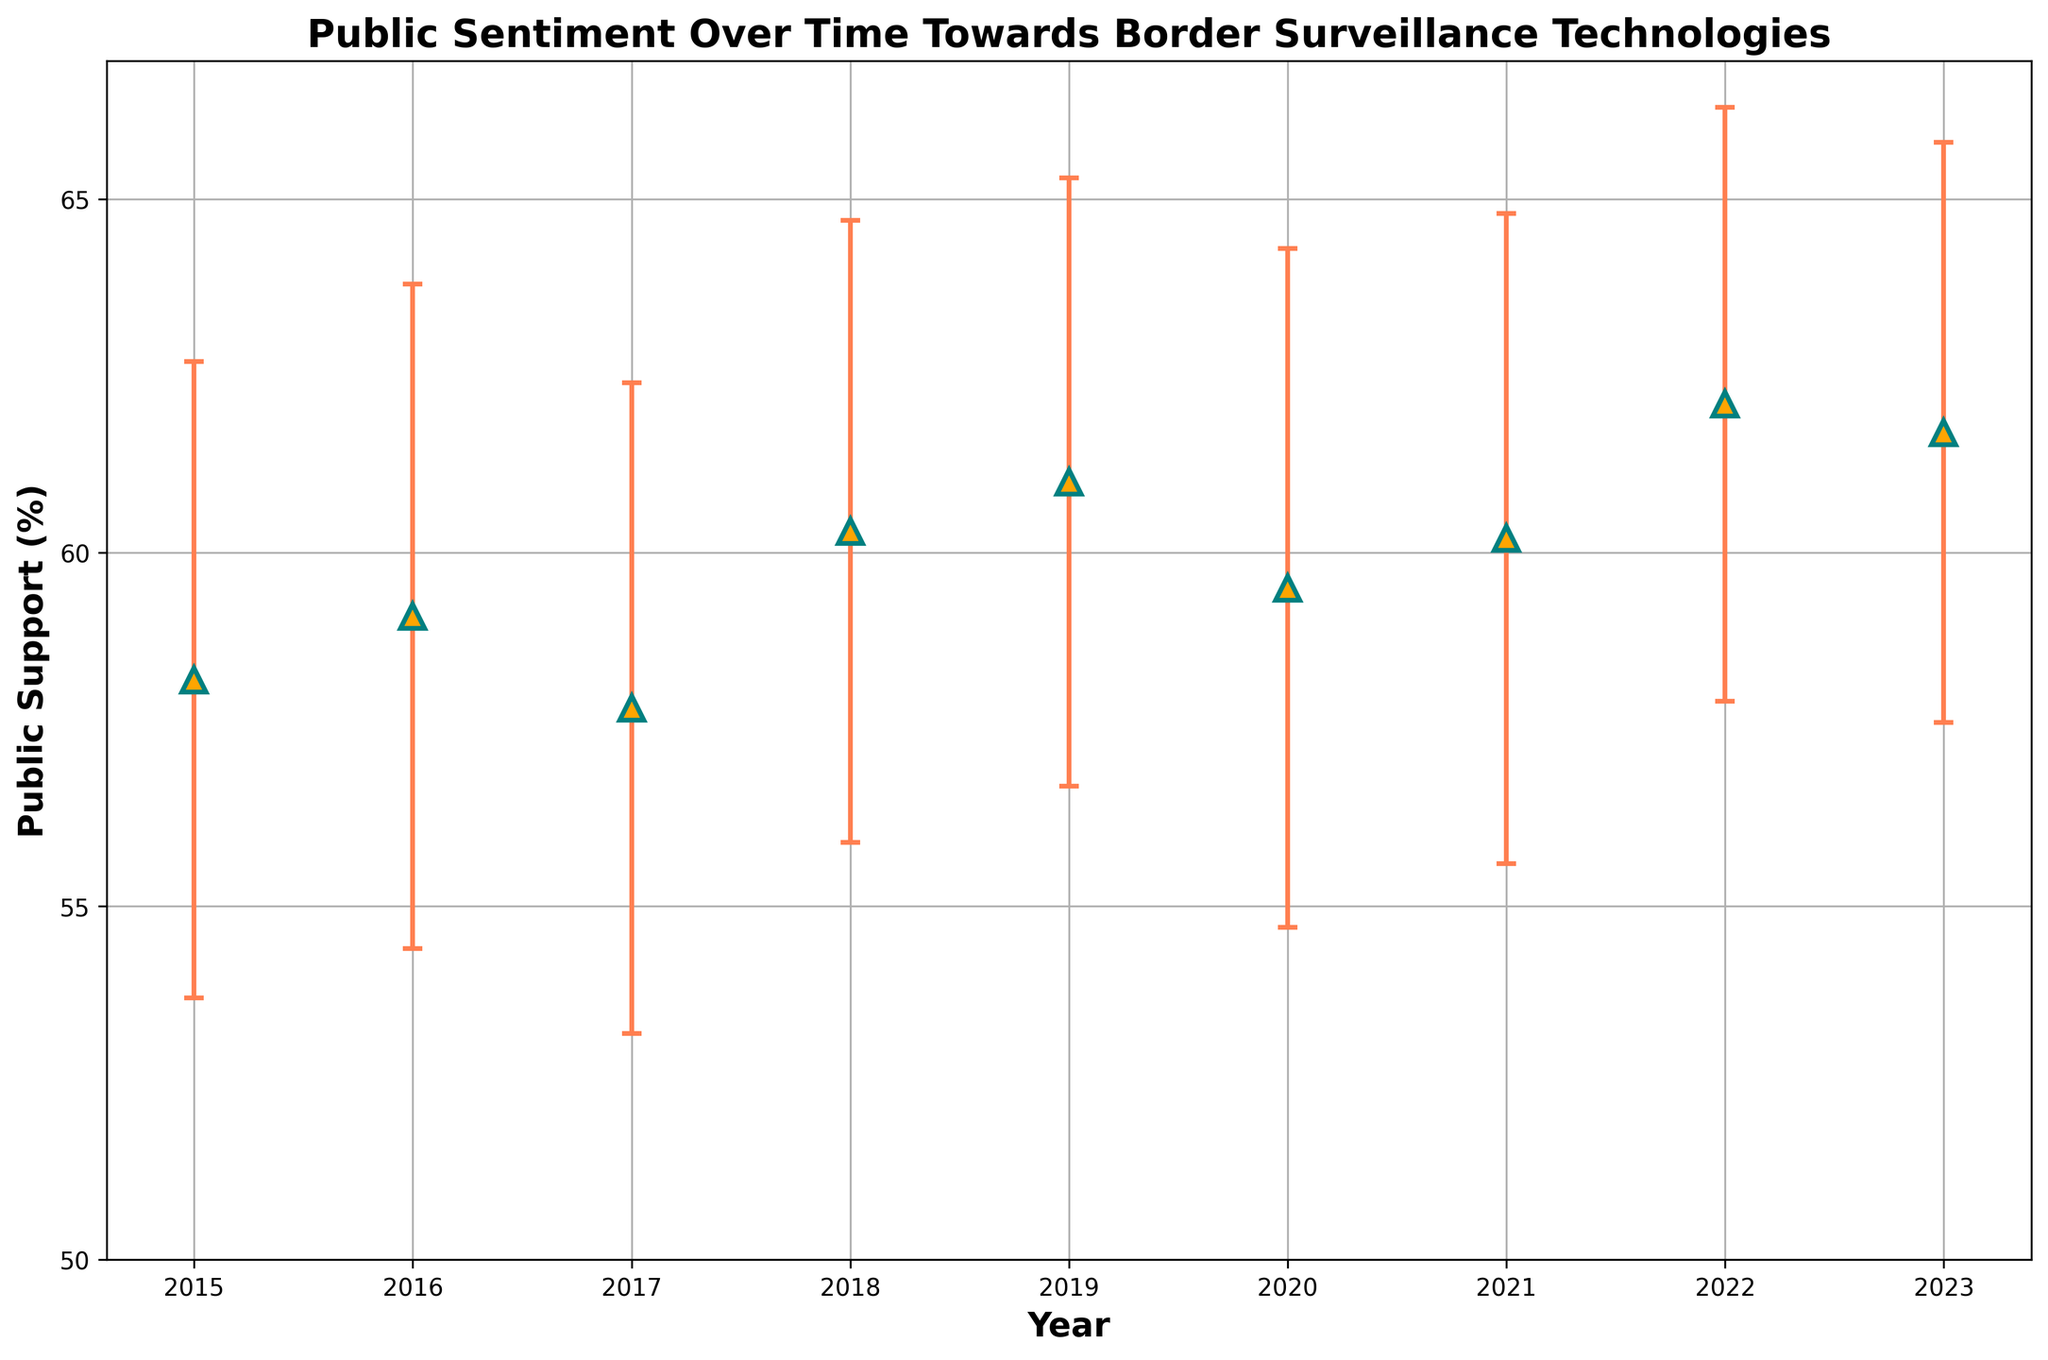What's the highest mean public support recorded, and in which year? We look for the highest public support mean in the y-axis values, which is 62.1% in the year 2022.
Answer: 62.1% in 2022 Which year had the lowest public support mean? We compare the mean values for each year and identify the lowest, which is 57.8% in the year 2017.
Answer: 2017 What's the overall trend in public support from 2015 to 2023? Examining the general direction of the mean support values from 2015 to 2023 reveals a gradual upward trend, despite some minor fluctuations.
Answer: Upward trend How does the public support in 2020 compare to 2022? Observing the graph, the mean public support in 2020 is 59.5%, while it is 62.1% in 2022, indicating an increase of 2.6%.
Answer: Increased by 2.6% What is the average of the public support means over the years 2015 to 2023? Adding the mean values for each year and dividing by the number of years (9), we get (58.2 + 59.1 + 57.8 + 60.3 + 61.0 + 59.5 + 60.2 + 62.1 + 61.7) / 9 ≈ 60.0.
Answer: 60.0 In which year was the standard deviation the smallest, and what does a smaller standard deviation indicate? The smallest standard deviation is 4.1 in the year 2023, which indicates less variability in the public opinion that year.
Answer: 2023, less variability Between which consecutive years was there the largest increase in mean public support? By comparing the differences in means between consecutive years, the largest increase is from 2017 to 2018 (60.3 - 57.8 = 2.5).
Answer: 2017 to 2018 What is the highest error margin observed in the plot, and in which year does it occur? The highest standard deviation (used as an error margin) is 4.8% in the year 2020.
Answer: 4.8% in 2020 What is the total change in mean public support from 2015 to 2023? Subtracting the mean in 2015 from the mean in 2023 gives us 61.7 - 58.2 = 3.5.
Answer: 3.5% 